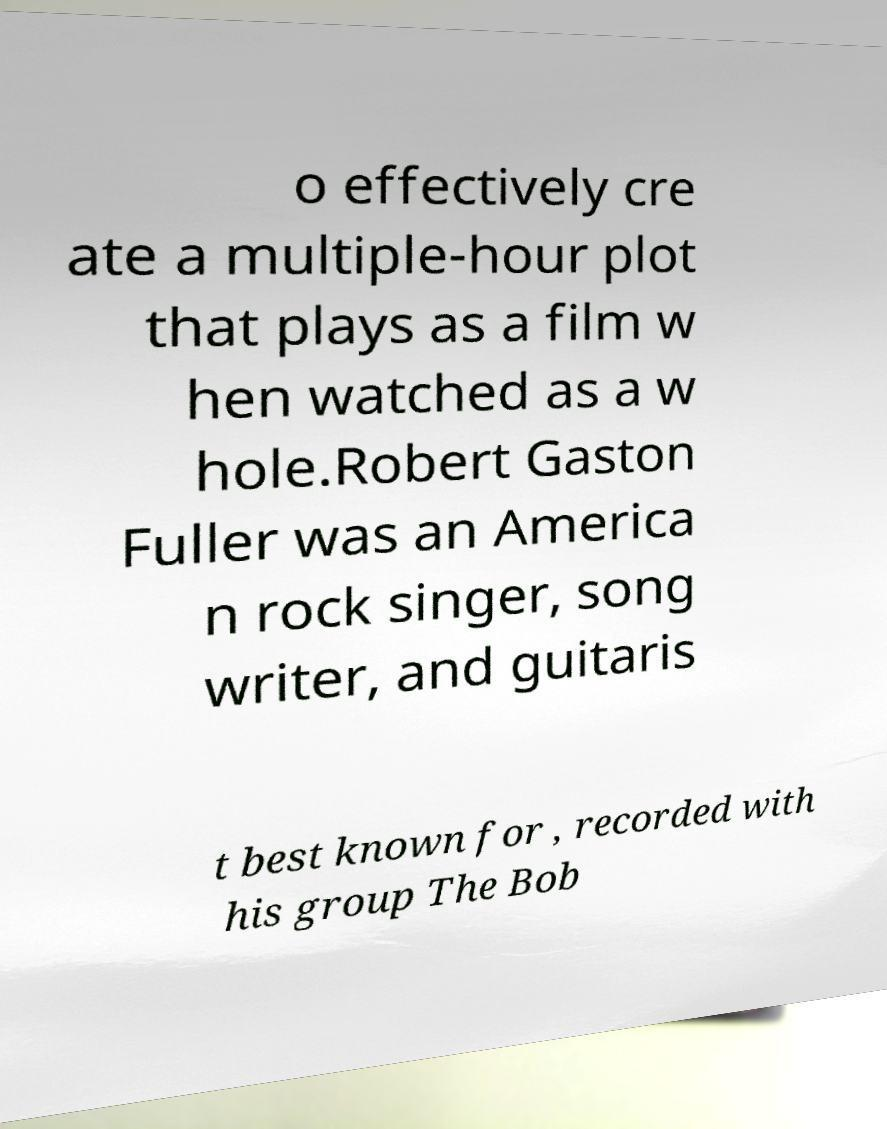Please identify and transcribe the text found in this image. o effectively cre ate a multiple-hour plot that plays as a film w hen watched as a w hole.Robert Gaston Fuller was an America n rock singer, song writer, and guitaris t best known for , recorded with his group The Bob 